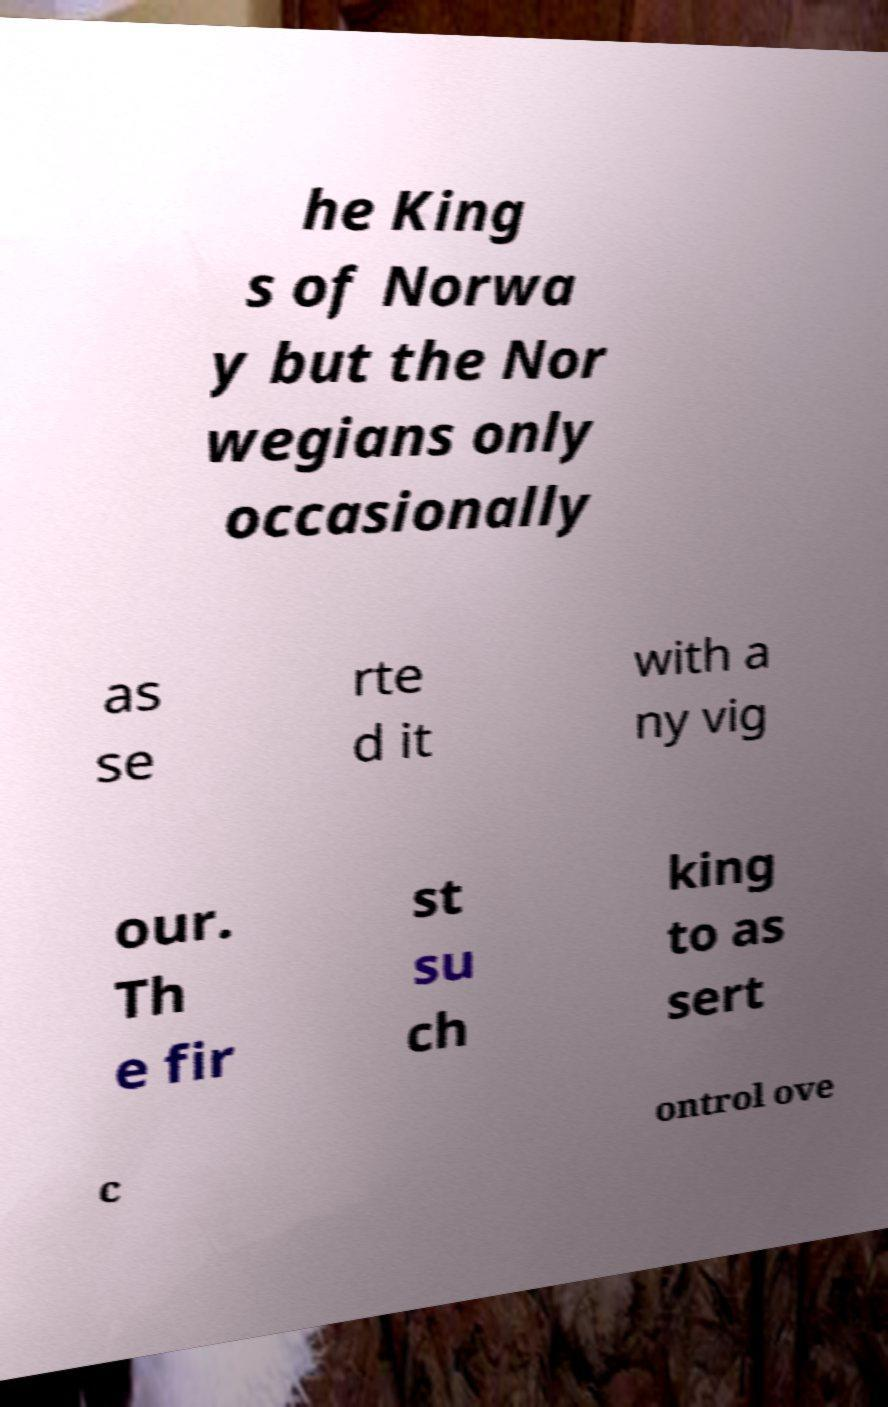Can you accurately transcribe the text from the provided image for me? he King s of Norwa y but the Nor wegians only occasionally as se rte d it with a ny vig our. Th e fir st su ch king to as sert c ontrol ove 